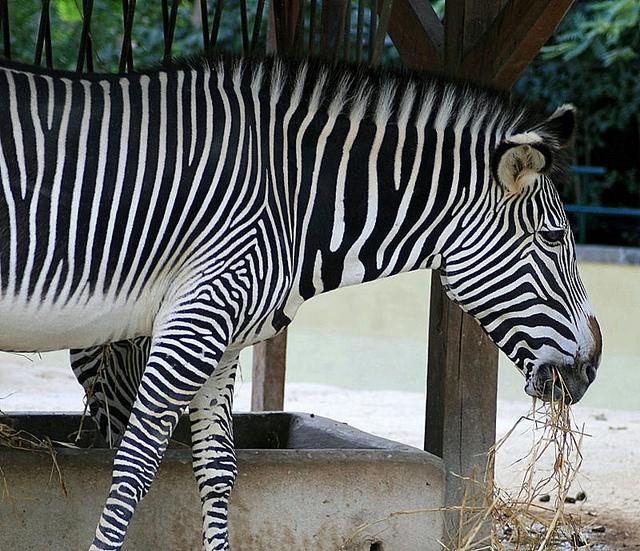What is the dominant color of the zebra?
Concise answer only. Black. Is the zebra out in the wild?
Be succinct. No. Does this animal have feathers?
Short answer required. No. What is the zebra eating?
Quick response, please. Hay. 